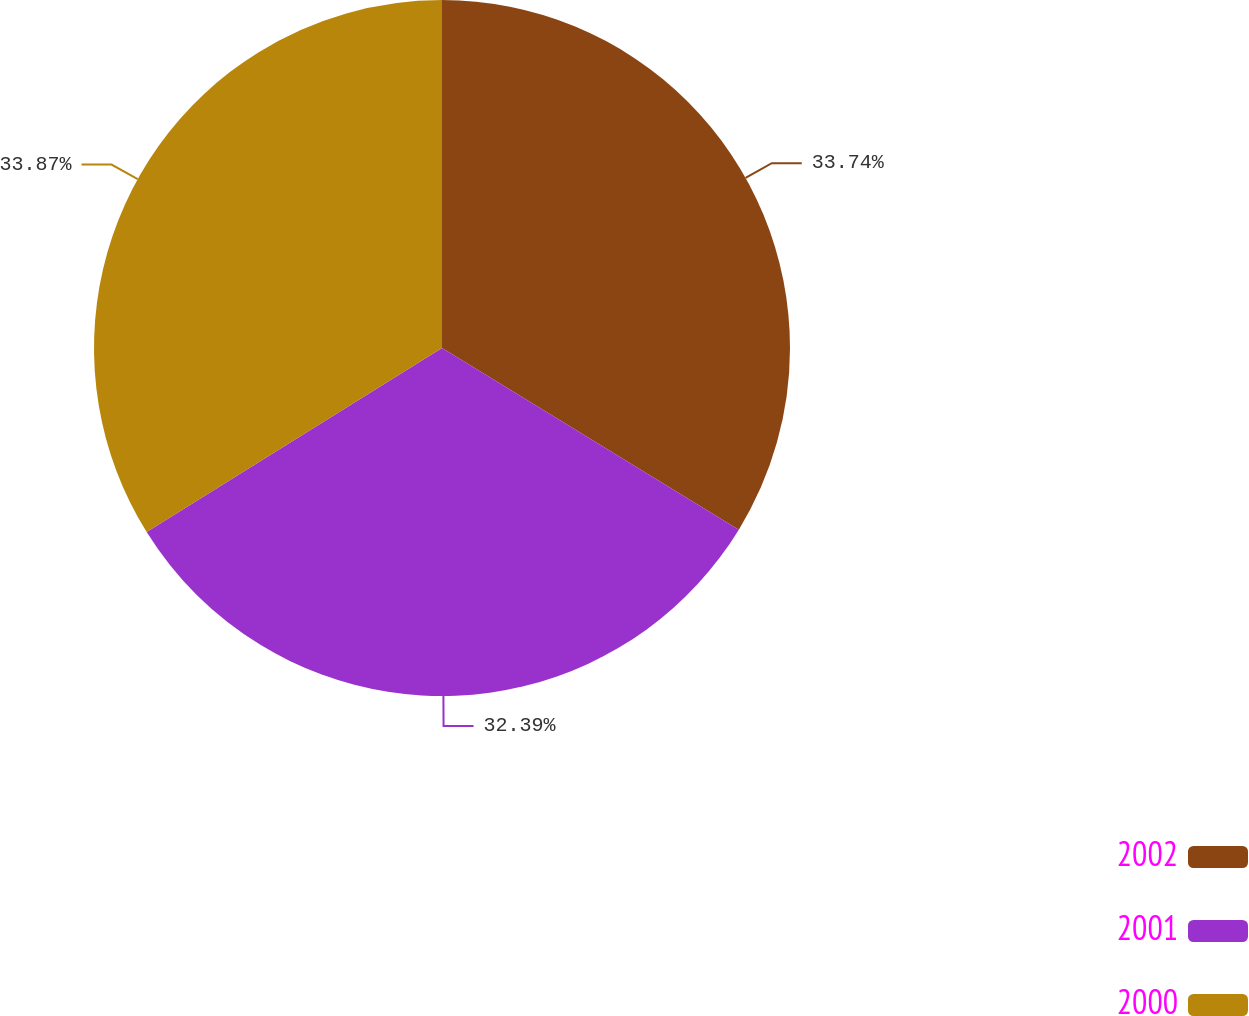<chart> <loc_0><loc_0><loc_500><loc_500><pie_chart><fcel>2002<fcel>2001<fcel>2000<nl><fcel>33.74%<fcel>32.39%<fcel>33.87%<nl></chart> 